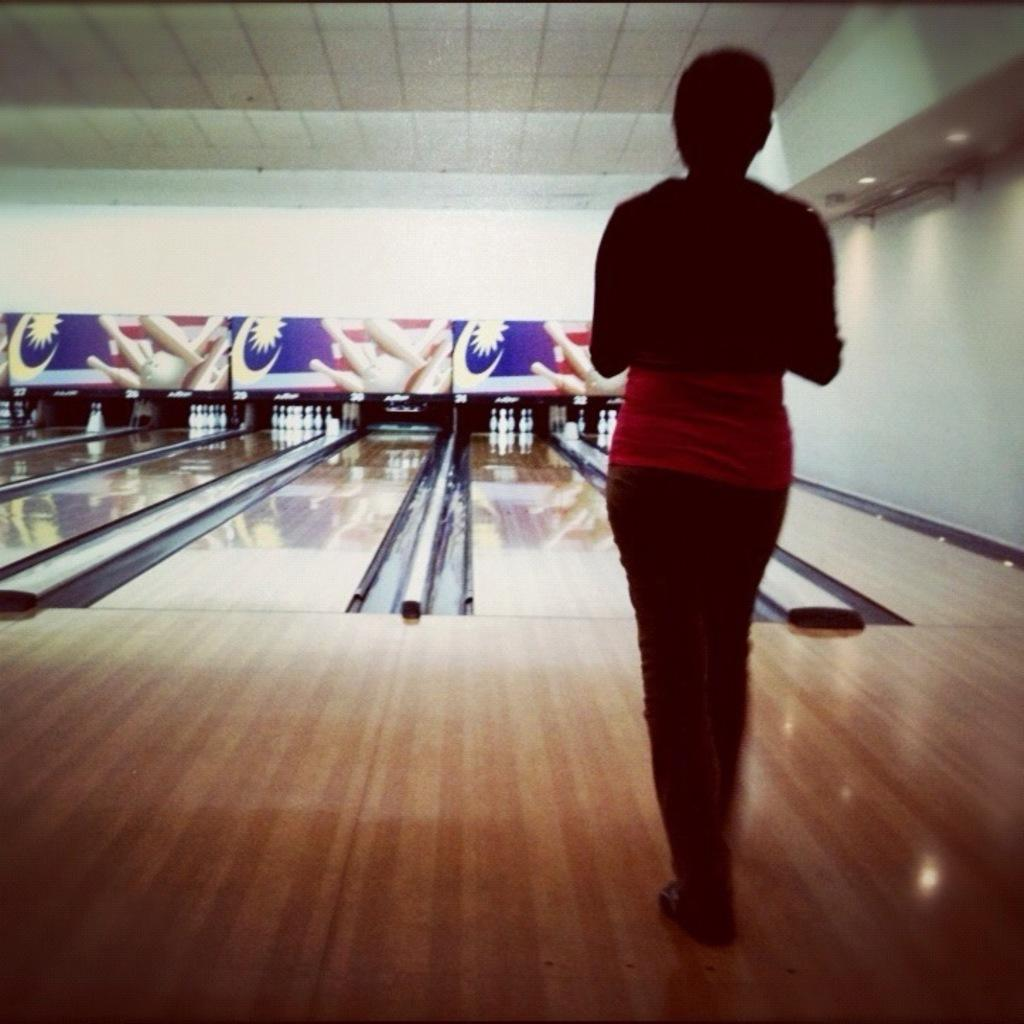What is the person in the image doing? There is a person walking in the image. What activity is taking place in the image? There is a bowling area in the image. What objects can be seen in the image besides the person and the bowling area? There are boards in the image. What can be seen on the right side of the image? There are lights visible on the right side of the image. What type of meat is being served on the square plate in the image? There is no meat or plate present in the image. 